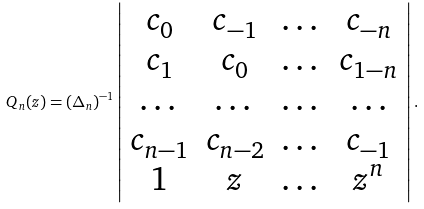Convert formula to latex. <formula><loc_0><loc_0><loc_500><loc_500>Q _ { n } ( z ) = ( \Delta _ { n } ) ^ { - 1 } \left | \begin{array} { c c c c } c _ { 0 } & c _ { - 1 } & \dots & c _ { - n } \\ c _ { 1 } & c _ { 0 } & \dots & c _ { 1 - n } \\ \dots & \dots & \dots & \dots \\ c _ { n - 1 } & c _ { n - 2 } & \dots & c _ { - 1 } \\ 1 & z & \dots & z ^ { n } \end{array} \right | .</formula> 